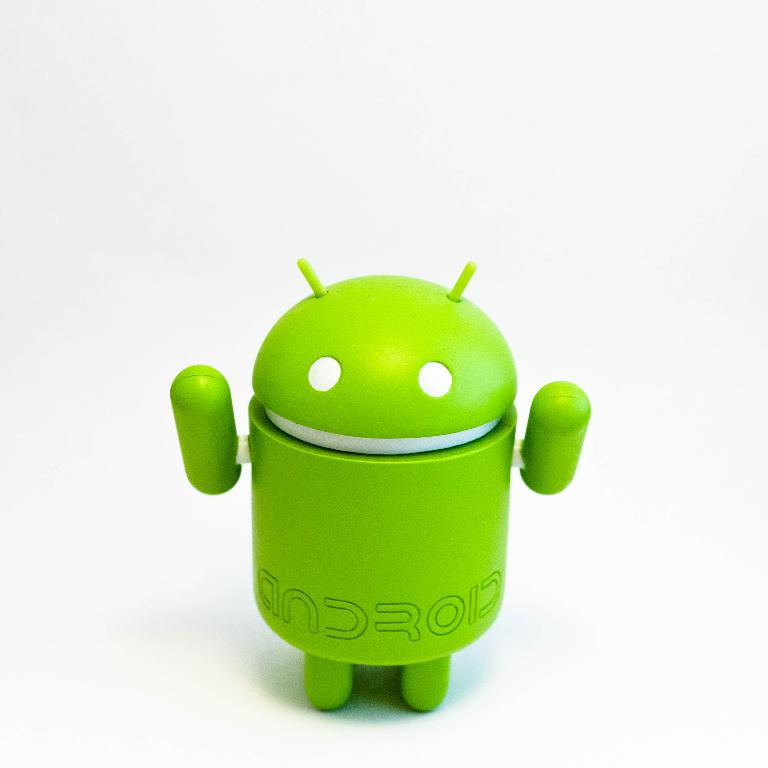Provide a one-sentence caption for the provided image. A vibrant green Android robot stands cheerfully on a pristine white background, symbolizing the playful and innovative spirit of Android technology. 